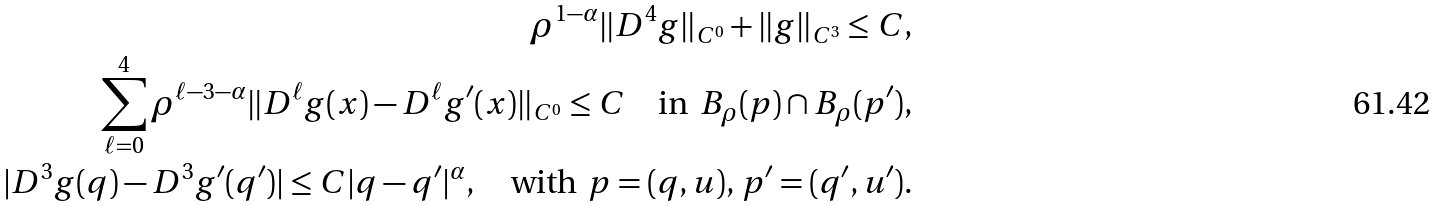Convert formula to latex. <formula><loc_0><loc_0><loc_500><loc_500>\rho ^ { 1 - \alpha } \| D ^ { 4 } g \| _ { C ^ { 0 } } + \| g \| _ { C ^ { 3 } } \leq C , \\ \sum _ { \ell = 0 } ^ { 4 } \rho ^ { \ell - 3 - \alpha } \| D ^ { \ell } g ( x ) - D ^ { \ell } g ^ { \prime } ( x ) \| _ { C ^ { 0 } } \leq C \quad \text {in } \, B _ { \rho } ( p ) \cap B _ { \rho } ( p ^ { \prime } ) , \\ | D ^ { 3 } g ( q ) - D ^ { 3 } g ^ { \prime } ( q ^ { \prime } ) | \leq C | q - q ^ { \prime } | ^ { \alpha } , \quad \text {with } \, p = ( q , u ) , \, p ^ { \prime } = ( q ^ { \prime } , u ^ { \prime } ) .</formula> 